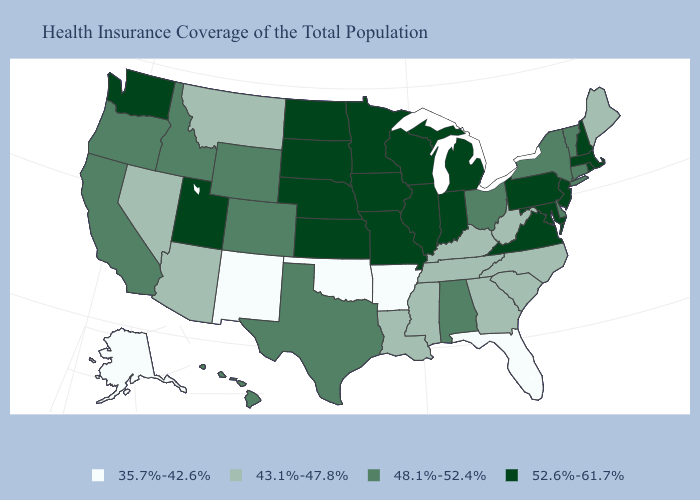Is the legend a continuous bar?
Be succinct. No. Name the states that have a value in the range 48.1%-52.4%?
Short answer required. Alabama, California, Colorado, Connecticut, Delaware, Hawaii, Idaho, New York, Ohio, Oregon, Texas, Vermont, Wyoming. What is the highest value in the MidWest ?
Quick response, please. 52.6%-61.7%. Does Maryland have the highest value in the South?
Short answer required. Yes. What is the highest value in the South ?
Quick response, please. 52.6%-61.7%. Among the states that border Nebraska , which have the highest value?
Be succinct. Iowa, Kansas, Missouri, South Dakota. Does Ohio have the highest value in the MidWest?
Give a very brief answer. No. How many symbols are there in the legend?
Answer briefly. 4. Name the states that have a value in the range 43.1%-47.8%?
Be succinct. Arizona, Georgia, Kentucky, Louisiana, Maine, Mississippi, Montana, Nevada, North Carolina, South Carolina, Tennessee, West Virginia. Does Louisiana have the same value as Rhode Island?
Answer briefly. No. Does Iowa have the highest value in the MidWest?
Write a very short answer. Yes. Name the states that have a value in the range 35.7%-42.6%?
Answer briefly. Alaska, Arkansas, Florida, New Mexico, Oklahoma. What is the value of Alaska?
Short answer required. 35.7%-42.6%. What is the value of New Hampshire?
Answer briefly. 52.6%-61.7%. Does Arkansas have the lowest value in the USA?
Concise answer only. Yes. 